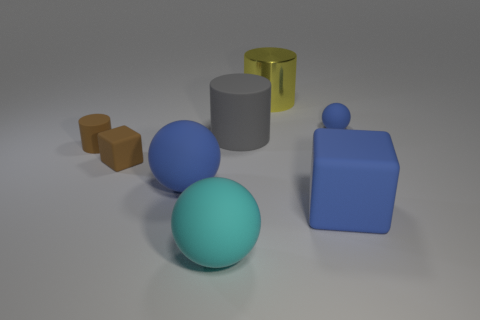There is a blue matte object on the left side of the big rubber object to the right of the large yellow shiny cylinder that is behind the cyan matte thing; what is its size?
Give a very brief answer. Large. Is the size of the blue rubber cube the same as the blue sphere that is on the left side of the small blue thing?
Give a very brief answer. Yes. What is the color of the thing behind the tiny blue matte sphere?
Make the answer very short. Yellow. There is a object that is the same color as the small block; what is its shape?
Your response must be concise. Cylinder. What is the shape of the shiny thing behind the tiny brown cylinder?
Your response must be concise. Cylinder. How many cyan objects are either matte things or metal objects?
Your answer should be very brief. 1. Is the gray cylinder made of the same material as the blue block?
Your answer should be very brief. Yes. There is a brown cylinder; how many brown blocks are behind it?
Your answer should be very brief. 0. There is a thing that is right of the large yellow cylinder and in front of the gray rubber object; what material is it?
Your answer should be compact. Rubber. What number of blocks are either large yellow metallic objects or large purple matte things?
Provide a succinct answer. 0. 